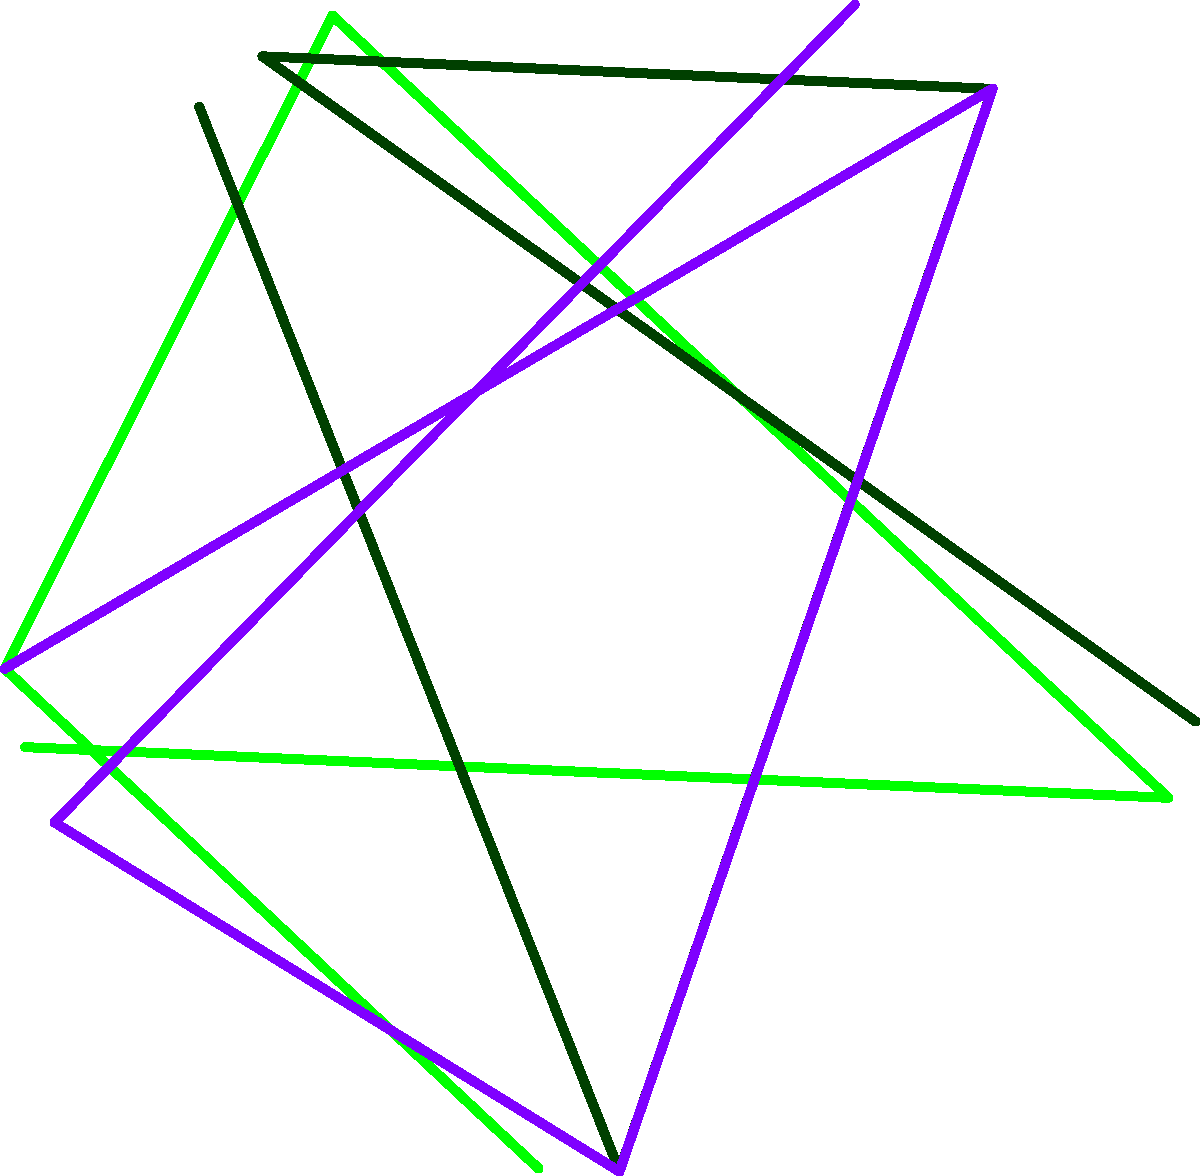Based on the polar line graph illustrating food trends in Los Angeles from 2015 to 2019, which trend shows the most consistent increase in popularity over the entire period? To answer this question, we need to analyze the trends for each food item:

1. Avocado (green line):
   - Starts at a high point in 2015
   - Increases until 2017
   - Slightly decreases in 2018 and 2019

2. Kale (dark green line):
   - Starts lower than avocado in 2015
   - Increases until 2017
   - Decreases in 2018 and 2019

3. Acai (purple line):
   - Starts at the lowest point in 2015
   - Shows a consistent increase each year from 2015 to 2019

Among these three trends, only acai shows a consistent increase throughout the entire period from 2015 to 2019. Both avocado and kale show increases initially but then decline in later years.

Therefore, the food trend that shows the most consistent increase in popularity over the entire period is acai.
Answer: Acai 